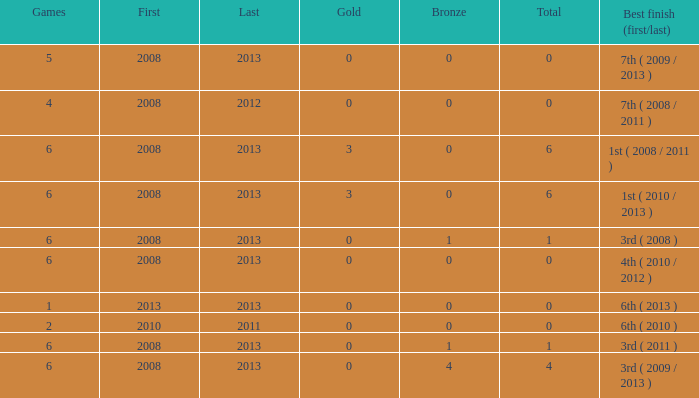Parse the full table. {'header': ['Games', 'First', 'Last', 'Gold', 'Bronze', 'Total', 'Best finish (first/last)'], 'rows': [['5', '2008', '2013', '0', '0', '0', '7th ( 2009 / 2013 )'], ['4', '2008', '2012', '0', '0', '0', '7th ( 2008 / 2011 )'], ['6', '2008', '2013', '3', '0', '6', '1st ( 2008 / 2011 )'], ['6', '2008', '2013', '3', '0', '6', '1st ( 2010 / 2013 )'], ['6', '2008', '2013', '0', '1', '1', '3rd ( 2008 )'], ['6', '2008', '2013', '0', '0', '0', '4th ( 2010 / 2012 )'], ['1', '2013', '2013', '0', '0', '0', '6th ( 2013 )'], ['2', '2010', '2011', '0', '0', '0', '6th ( 2010 )'], ['6', '2008', '2013', '0', '1', '1', '3rd ( 2011 )'], ['6', '2008', '2013', '0', '4', '4', '3rd ( 2009 / 2013 )']]} What is the latest first year with 0 total medals and over 0 golds? 2008.0. 